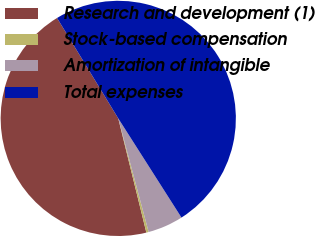<chart> <loc_0><loc_0><loc_500><loc_500><pie_chart><fcel>Research and development (1)<fcel>Stock-based compensation<fcel>Amortization of intangible<fcel>Total expenses<nl><fcel>45.13%<fcel>0.32%<fcel>4.87%<fcel>49.68%<nl></chart> 